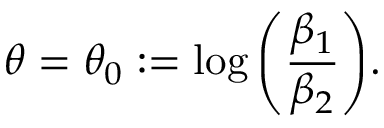<formula> <loc_0><loc_0><loc_500><loc_500>\theta = \theta _ { 0 } \colon = \log { \left ( \frac { \beta _ { 1 } } { \beta _ { 2 } } \right ) } .</formula> 